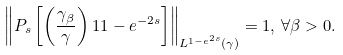Convert formula to latex. <formula><loc_0><loc_0><loc_500><loc_500>\left \| P _ { s } \left [ \left ( \frac { \gamma _ { \beta } } { \gamma } \right ) ^ { } { 1 } { 1 - e ^ { - 2 s } } \right ] \right \| _ { L ^ { 1 - e ^ { 2 s } } ( \gamma ) } = 1 , \, \forall \beta > 0 .</formula> 